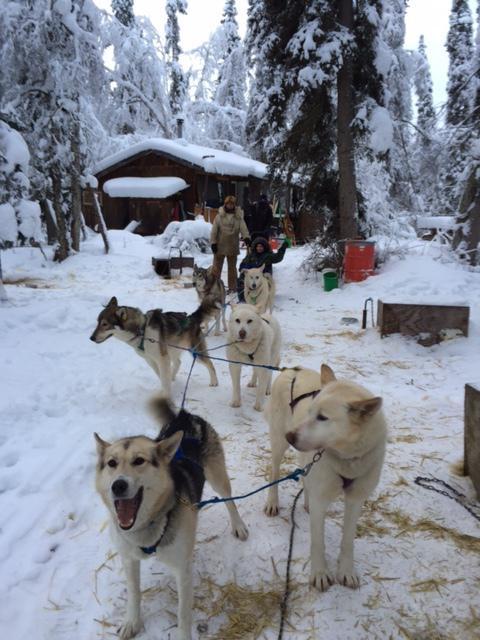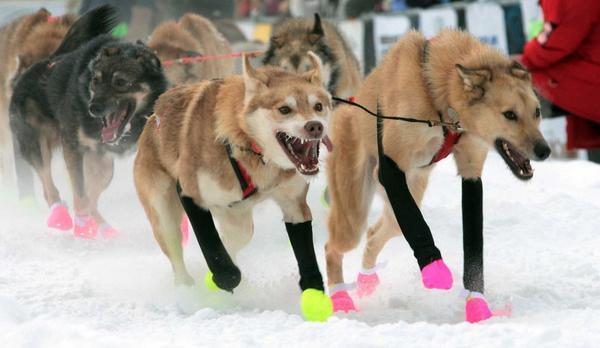The first image is the image on the left, the second image is the image on the right. For the images shown, is this caption "sled dogs are wearing protective foot coverings" true? Answer yes or no. Yes. The first image is the image on the left, the second image is the image on the right. Analyze the images presented: Is the assertion "Some dogs are wearing booties." valid? Answer yes or no. Yes. 